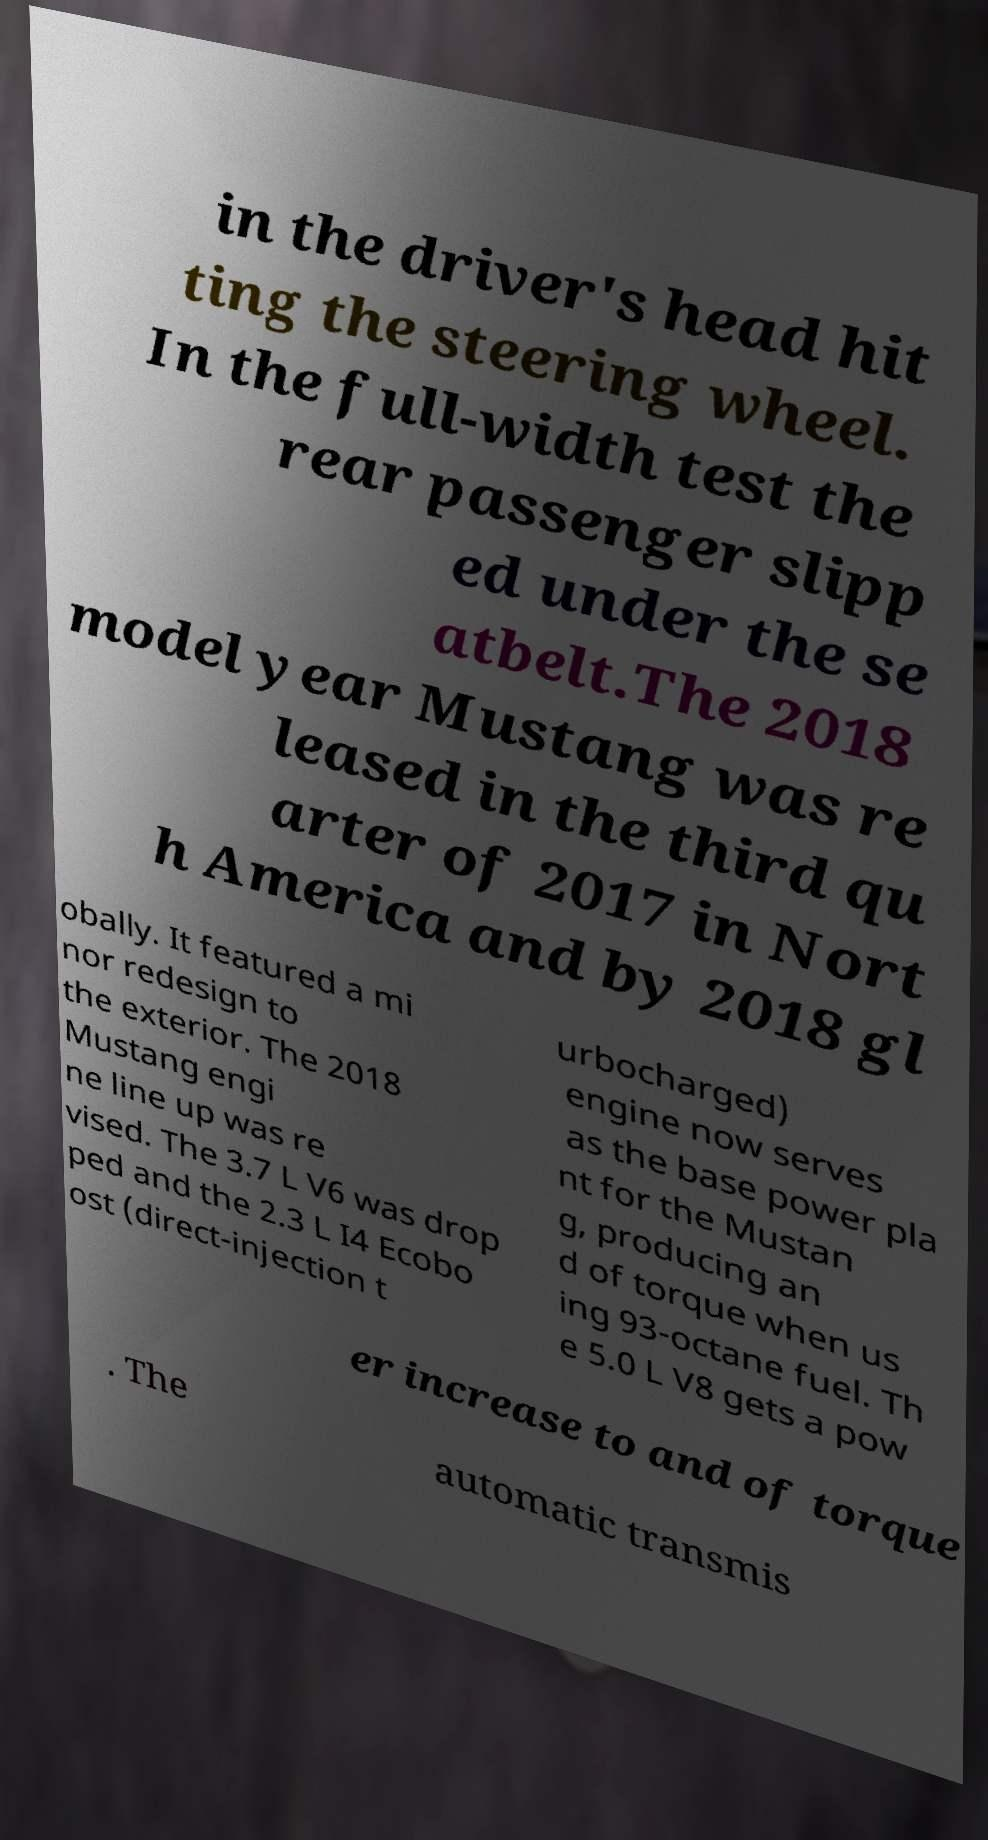Please read and relay the text visible in this image. What does it say? in the driver's head hit ting the steering wheel. In the full-width test the rear passenger slipp ed under the se atbelt.The 2018 model year Mustang was re leased in the third qu arter of 2017 in Nort h America and by 2018 gl obally. It featured a mi nor redesign to the exterior. The 2018 Mustang engi ne line up was re vised. The 3.7 L V6 was drop ped and the 2.3 L I4 Ecobo ost (direct-injection t urbocharged) engine now serves as the base power pla nt for the Mustan g, producing an d of torque when us ing 93-octane fuel. Th e 5.0 L V8 gets a pow er increase to and of torque . The automatic transmis 